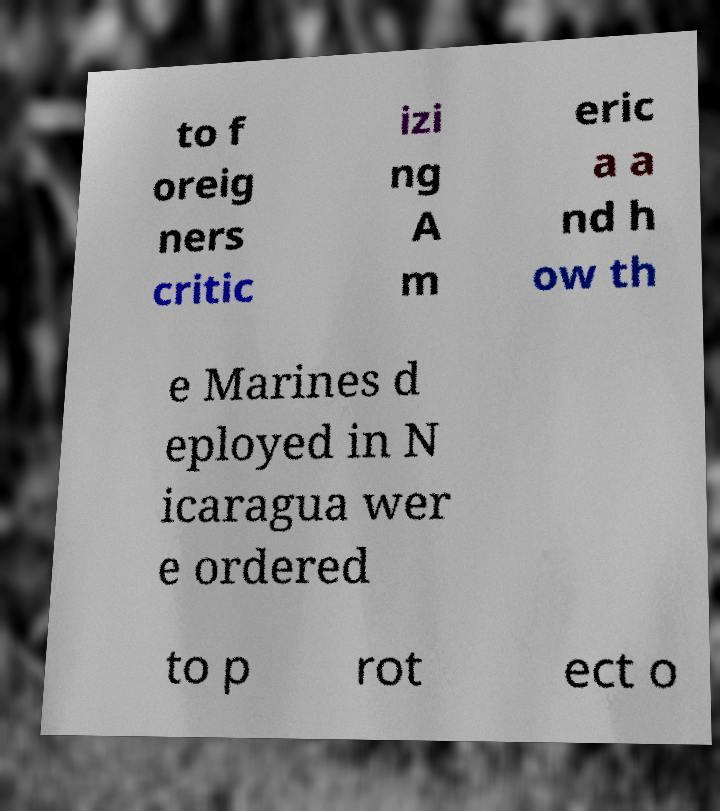I need the written content from this picture converted into text. Can you do that? to f oreig ners critic izi ng A m eric a a nd h ow th e Marines d eployed in N icaragua wer e ordered to p rot ect o 